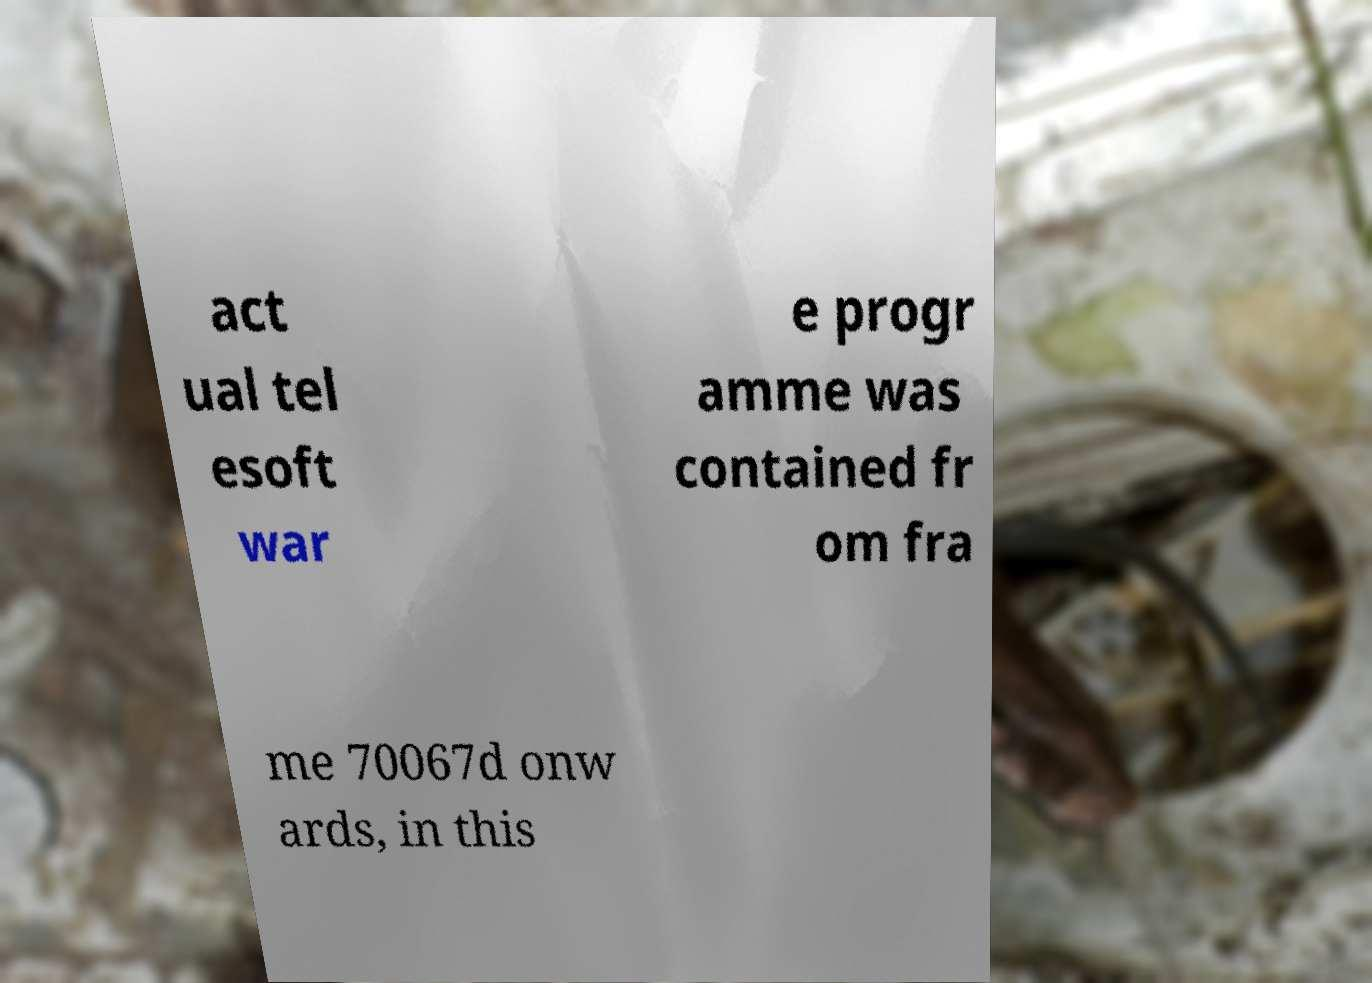Could you assist in decoding the text presented in this image and type it out clearly? act ual tel esoft war e progr amme was contained fr om fra me 70067d onw ards, in this 